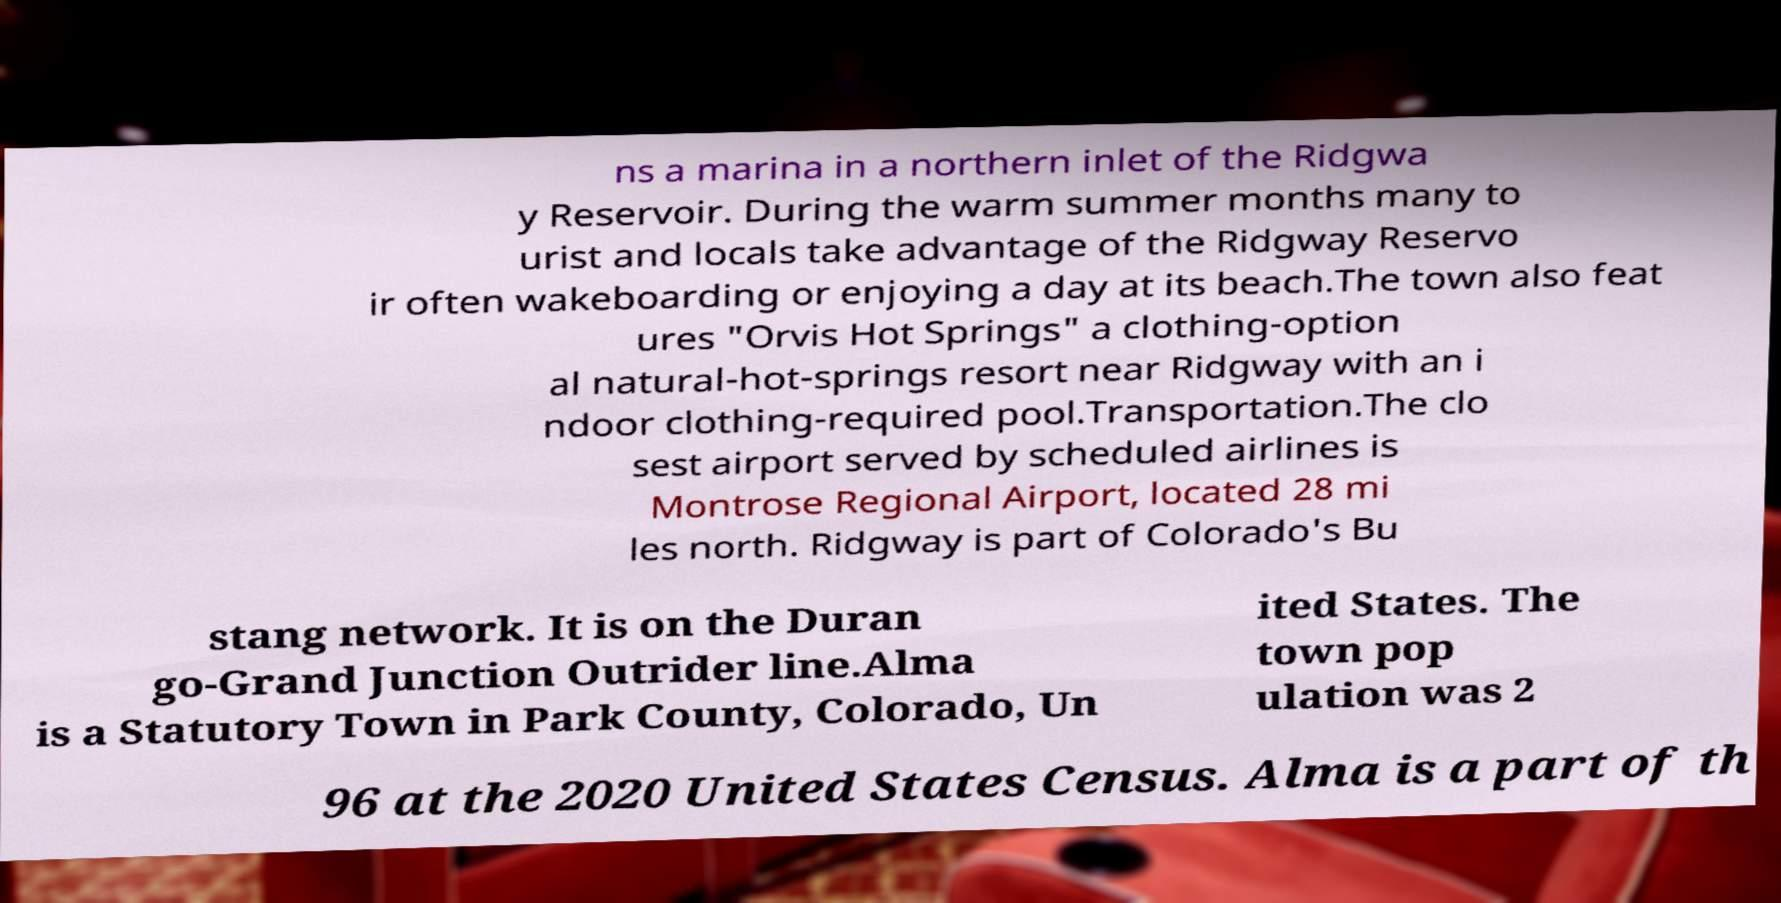Could you extract and type out the text from this image? ns a marina in a northern inlet of the Ridgwa y Reservoir. During the warm summer months many to urist and locals take advantage of the Ridgway Reservo ir often wakeboarding or enjoying a day at its beach.The town also feat ures "Orvis Hot Springs" a clothing-option al natural-hot-springs resort near Ridgway with an i ndoor clothing-required pool.Transportation.The clo sest airport served by scheduled airlines is Montrose Regional Airport, located 28 mi les north. Ridgway is part of Colorado's Bu stang network. It is on the Duran go-Grand Junction Outrider line.Alma is a Statutory Town in Park County, Colorado, Un ited States. The town pop ulation was 2 96 at the 2020 United States Census. Alma is a part of th 